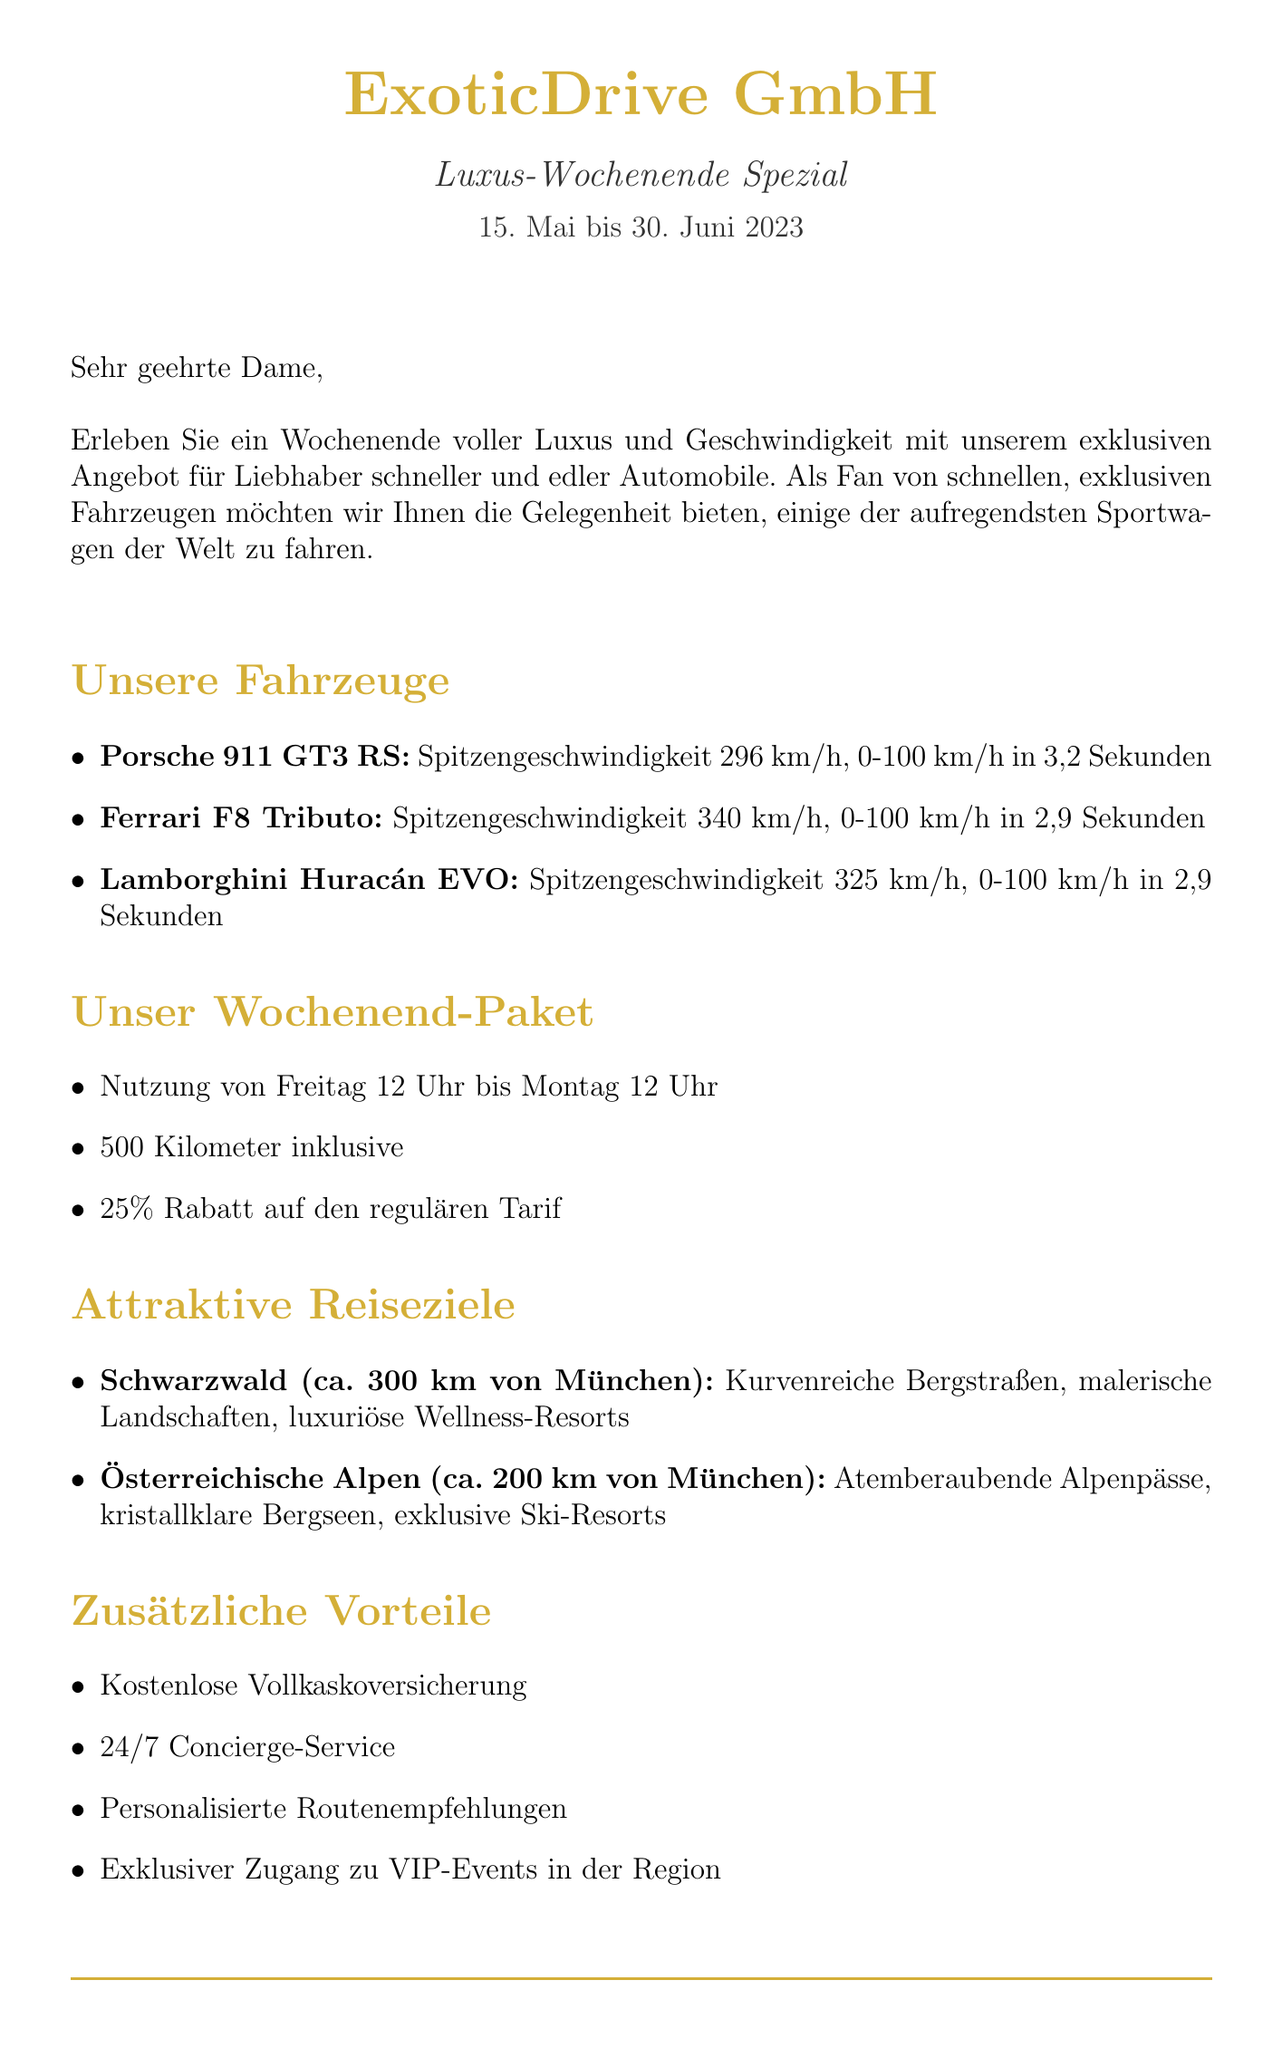Was ist der Name des Unternehmens? Das Unternehmen heißt ExoticDrive GmbH.
Answer: ExoticDrive GmbH Was ist der Name der Promotion? Die Promotion wird als Luxus-Wochenende Spezial bezeichnet.
Answer: Luxus-Wochenende Spezial Wann läuft die Promotion? Sie läuft vom 15. Mai bis 30. Juni 2023.
Answer: 15. Mai bis 30. Juni 2023 Welche Fahrzeuge werden in der Promotion angeboten? Die Fahrzeuge sind Porsche 911 GT3 RS, Ferrari F8 Tributo und Lamborghini Huracán EVO.
Answer: Porsche 911 GT3 RS, Ferrari F8 Tributo, Lamborghini Huracán EVO Wie viel Rabatt gibt es auf den regulären Tarif? Es gibt einen Rabatt von 25 Prozent.
Answer: 25 Prozent Wie lange dauert das Wochenend-Paket? Das Paket läuft von Freitag 12 Uhr bis Montag 12 Uhr.
Answer: Freitag 12 Uhr bis Montag 12 Uhr Was ist eine der zusätzlichen Vorteile? Eine der zusätzlichen Vorteile ist die kostenlose Vollkaskoversicherung.
Answer: Kostenlose Vollkaskoversicherung Wie viele Kilometer sind im Angebot inklusive? Im Angebot sind 500 Kilometer inklusive.
Answer: 500 Kilometer Wie kann man das Fahrzeug buchen? Man kann online oder telefonisch buchen.
Answer: Online oder telefonisch Wer hat eine positive Erfahrung mit dem Porsche 911 GT3 RS geteilt? Die positive Erfahrung wurde von Sabine Schmidt geteilt.
Answer: Sabine Schmidt 